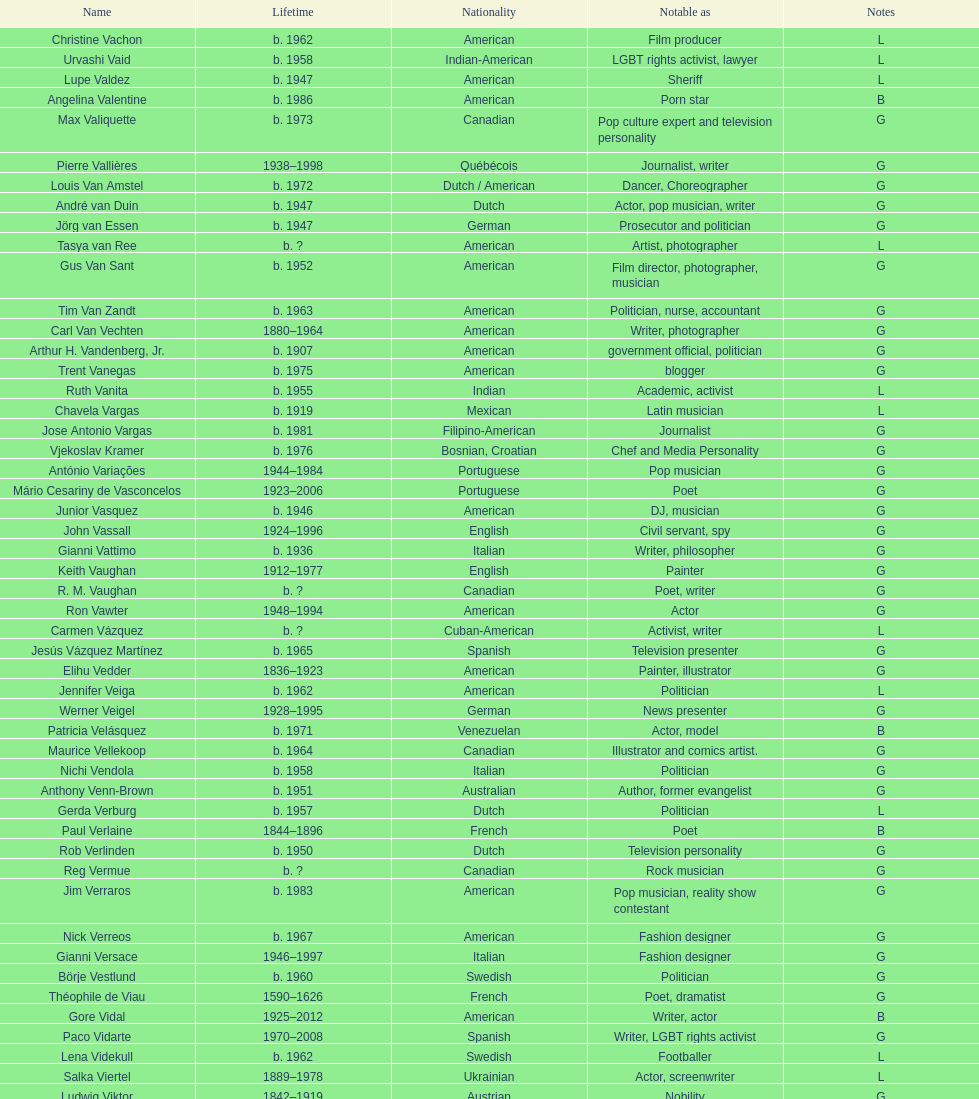How old was pierre vallieres before he died? 60. 